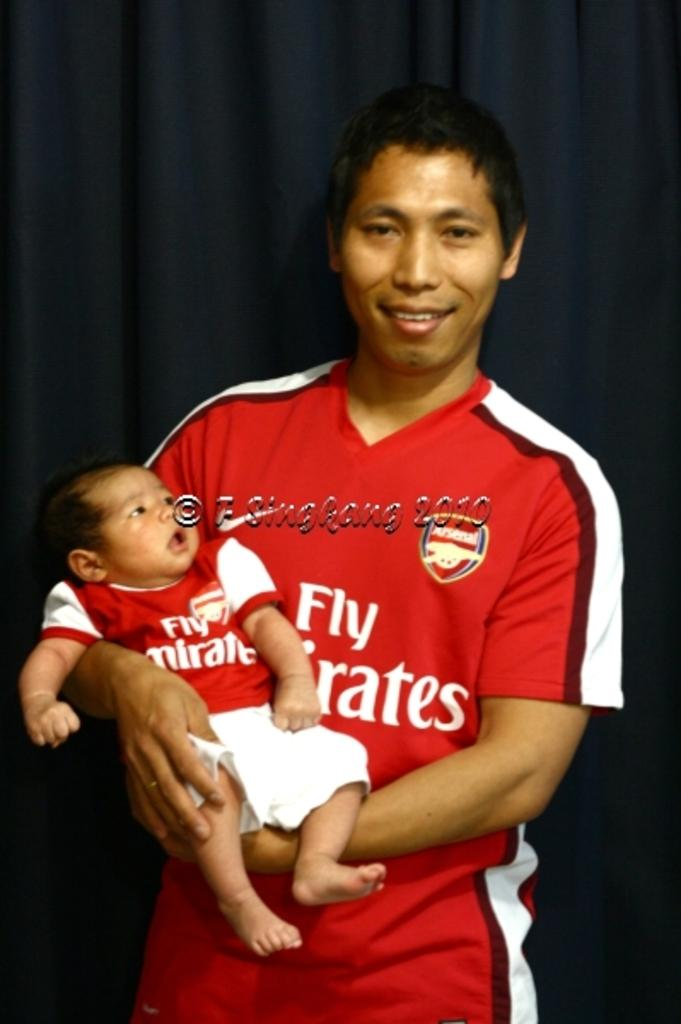<image>
Write a terse but informative summary of the picture. the words fly emirates that is on a jersey 